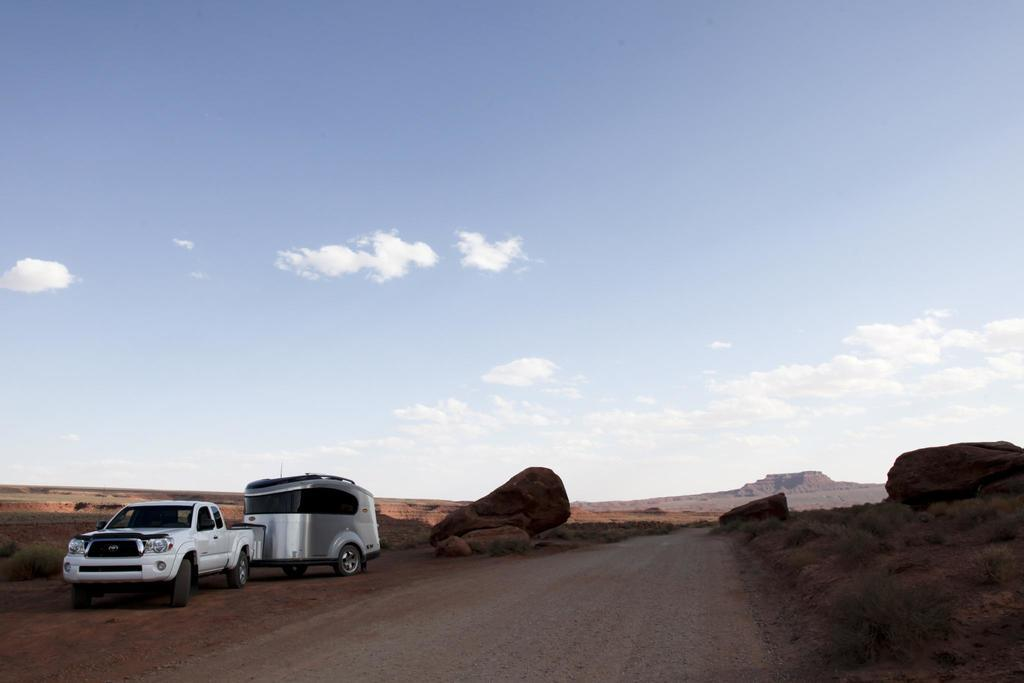What types of objects are on the ground in the image? There are vehicles on the ground in the image. What other elements can be seen in the image besides the vehicles? There are plants and rocks in the image. What can be seen in the background of the image? The sky is visible in the background of the image. How many balloons are floating above the vehicles in the image? There are no balloons present in the image. What type of basin can be seen holding water in the image? There is no basin holding water in the image. 